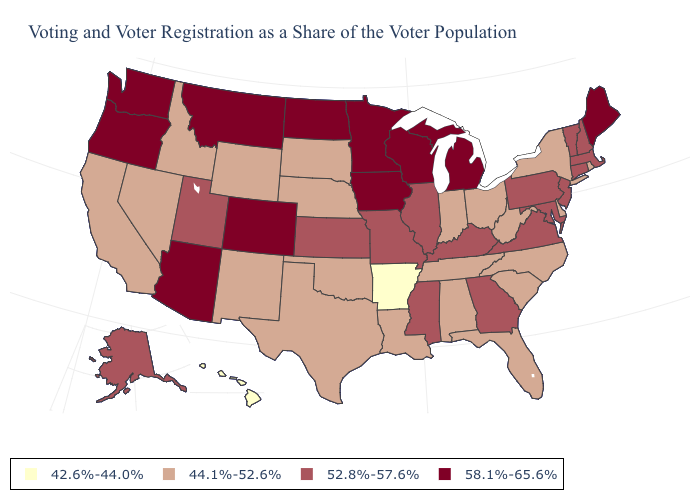Does Alaska have the same value as California?
Short answer required. No. Name the states that have a value in the range 52.8%-57.6%?
Be succinct. Alaska, Connecticut, Georgia, Illinois, Kansas, Kentucky, Maryland, Massachusetts, Mississippi, Missouri, New Hampshire, New Jersey, Pennsylvania, Utah, Vermont, Virginia. Name the states that have a value in the range 42.6%-44.0%?
Keep it brief. Arkansas, Hawaii. Does the first symbol in the legend represent the smallest category?
Answer briefly. Yes. Does Indiana have the same value as Oregon?
Short answer required. No. What is the highest value in the MidWest ?
Quick response, please. 58.1%-65.6%. Which states have the lowest value in the Northeast?
Short answer required. New York, Rhode Island. Which states have the lowest value in the South?
Short answer required. Arkansas. How many symbols are there in the legend?
Concise answer only. 4. What is the lowest value in states that border Washington?
Concise answer only. 44.1%-52.6%. Among the states that border Illinois , which have the highest value?
Be succinct. Iowa, Wisconsin. What is the value of Missouri?
Be succinct. 52.8%-57.6%. What is the value of Delaware?
Quick response, please. 44.1%-52.6%. Among the states that border Mississippi , which have the highest value?
Quick response, please. Alabama, Louisiana, Tennessee. What is the value of North Carolina?
Keep it brief. 44.1%-52.6%. 